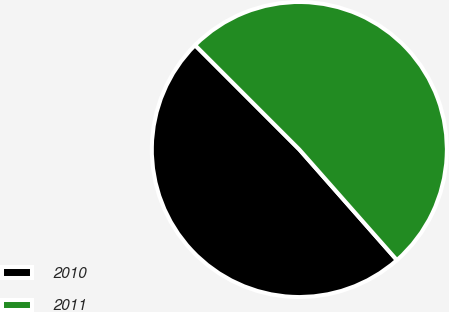Convert chart to OTSL. <chart><loc_0><loc_0><loc_500><loc_500><pie_chart><fcel>2010<fcel>2011<nl><fcel>49.01%<fcel>50.99%<nl></chart> 